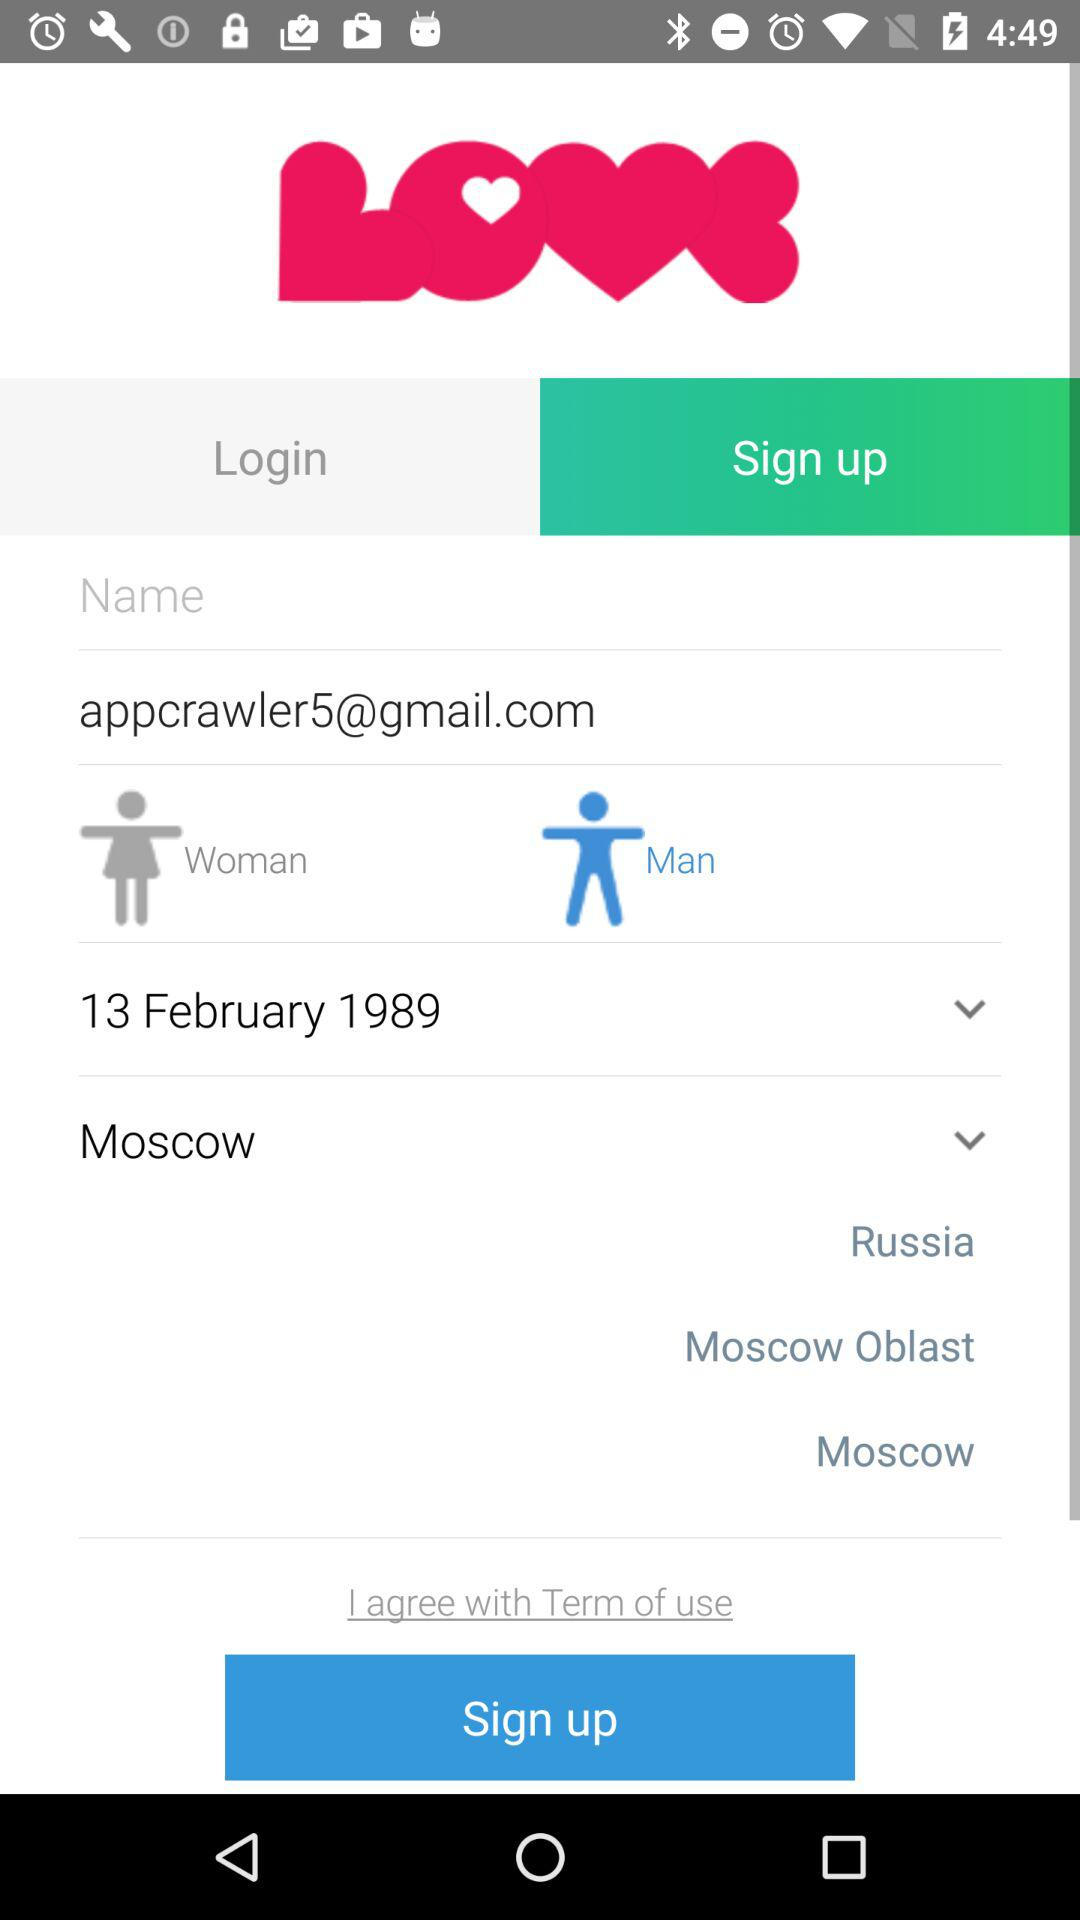What is the name of the application? The name of the application is "LOVE". 